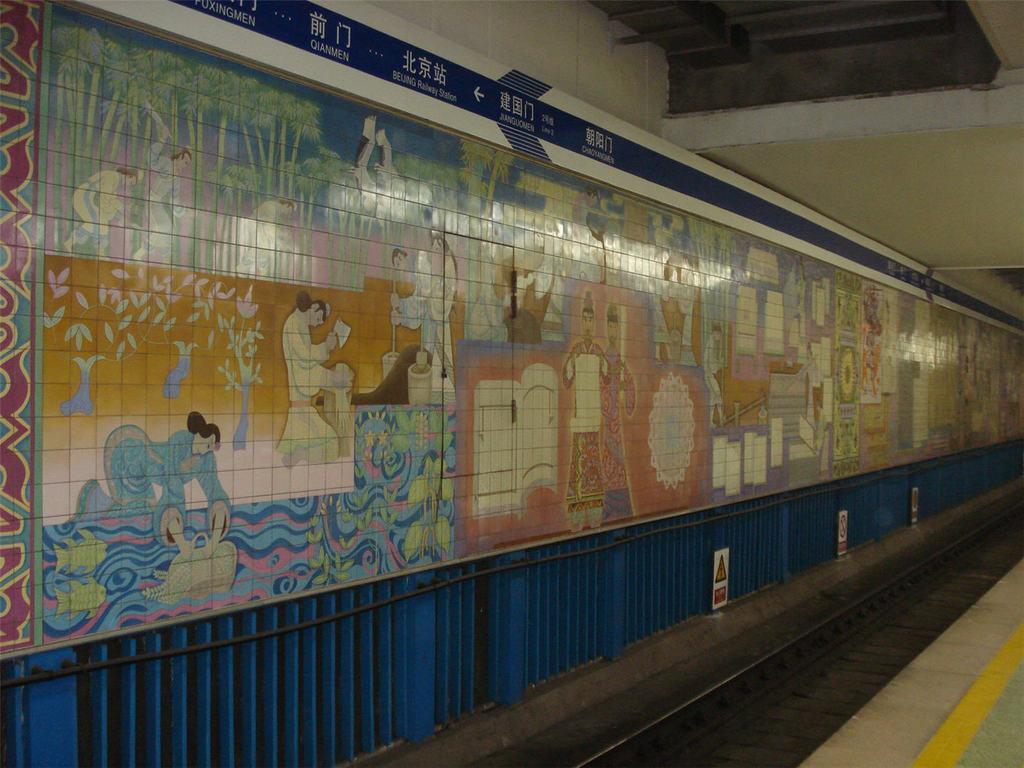How would you summarize this image in a sentence or two? At the bottom portion of the picture we can see the floor. On the left side of the picture we can see colorful tiles. We can see trees, people and few other objects. We can see boards at the bottom. 